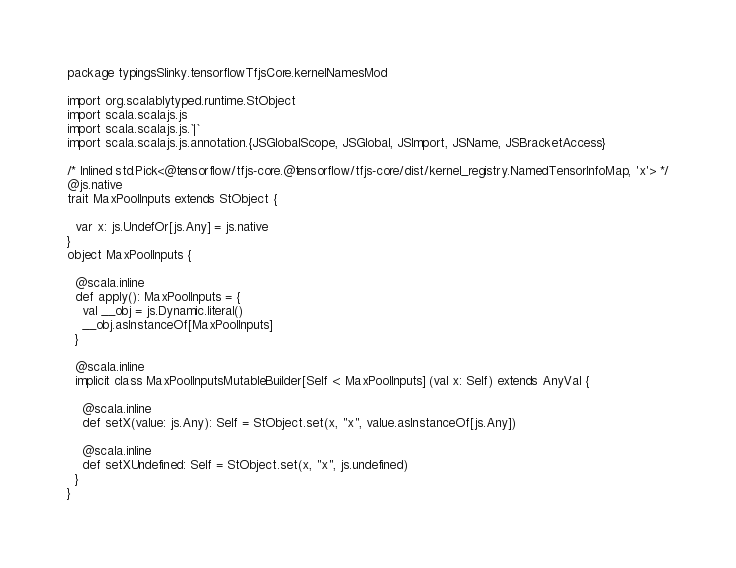Convert code to text. <code><loc_0><loc_0><loc_500><loc_500><_Scala_>package typingsSlinky.tensorflowTfjsCore.kernelNamesMod

import org.scalablytyped.runtime.StObject
import scala.scalajs.js
import scala.scalajs.js.`|`
import scala.scalajs.js.annotation.{JSGlobalScope, JSGlobal, JSImport, JSName, JSBracketAccess}

/* Inlined std.Pick<@tensorflow/tfjs-core.@tensorflow/tfjs-core/dist/kernel_registry.NamedTensorInfoMap, 'x'> */
@js.native
trait MaxPoolInputs extends StObject {
  
  var x: js.UndefOr[js.Any] = js.native
}
object MaxPoolInputs {
  
  @scala.inline
  def apply(): MaxPoolInputs = {
    val __obj = js.Dynamic.literal()
    __obj.asInstanceOf[MaxPoolInputs]
  }
  
  @scala.inline
  implicit class MaxPoolInputsMutableBuilder[Self <: MaxPoolInputs] (val x: Self) extends AnyVal {
    
    @scala.inline
    def setX(value: js.Any): Self = StObject.set(x, "x", value.asInstanceOf[js.Any])
    
    @scala.inline
    def setXUndefined: Self = StObject.set(x, "x", js.undefined)
  }
}
</code> 